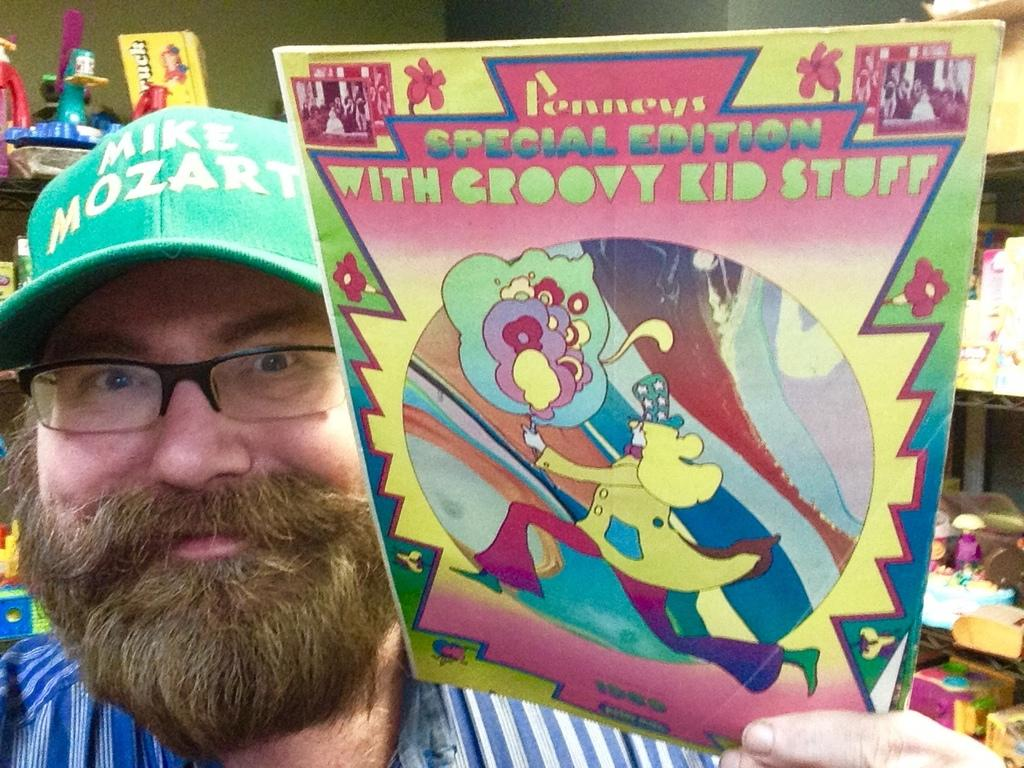What is the man in the image holding? The man is holding a book in his hand. What can be seen on the man's face in the image? The man is wearing spectacles and is smiling. What is on the man's head in the image? The man is wearing a green color cap on his head. What is visible in the background of the image? There is a wall in the background of the image. What type of brick is the man using to create a sheet in the image? There is no brick or sheet present in the image, and the man is not depicted as a creator. 